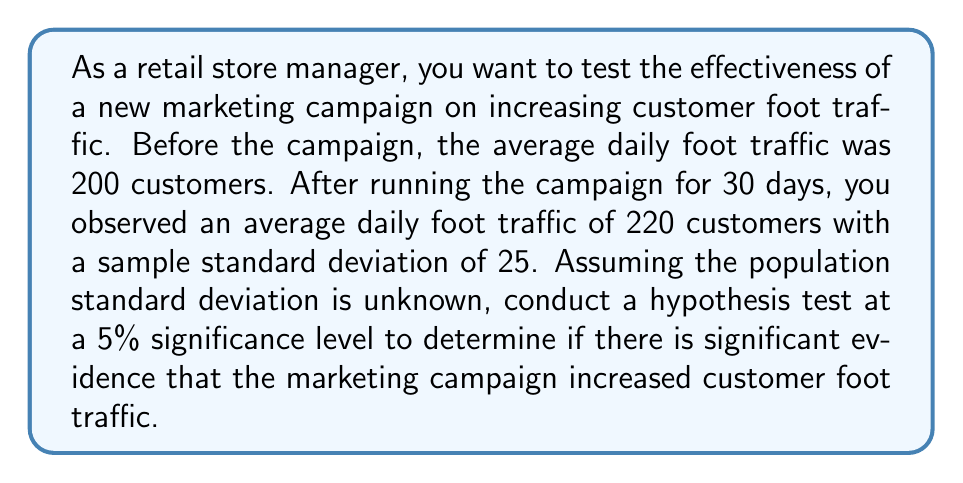Help me with this question. 1. Define the hypotheses:
   $H_0: \mu = 200$ (null hypothesis)
   $H_a: \mu > 200$ (alternative hypothesis)

2. Choose the significance level: $\alpha = 0.05$

3. Calculate the test statistic:
   $t = \frac{\bar{x} - \mu_0}{s/\sqrt{n}}$
   Where:
   $\bar{x} = 220$ (sample mean)
   $\mu_0 = 200$ (hypothesized population mean)
   $s = 25$ (sample standard deviation)
   $n = 30$ (sample size)

   $t = \frac{220 - 200}{25/\sqrt{30}} = \frac{20}{4.56} = 4.39$

4. Determine the critical value:
   Degrees of freedom: $df = n - 1 = 30 - 1 = 29$
   For a one-tailed test with $\alpha = 0.05$ and $df = 29$, the critical t-value is approximately 1.699.

5. Compare the test statistic to the critical value:
   $4.39 > 1.699$, so we reject the null hypothesis.

6. Calculate the p-value:
   Using a t-distribution table or calculator, we find that the p-value for $t = 4.39$ with $df = 29$ is approximately 0.0001, which is less than $\alpha = 0.05$.

7. Conclusion:
   Since the test statistic (4.39) is greater than the critical value (1.699) and the p-value (0.0001) is less than the significance level (0.05), we reject the null hypothesis. There is significant evidence to conclude that the marketing campaign increased customer foot traffic.
Answer: Reject $H_0$; significant evidence of increased foot traffic (t = 4.39, p < 0.05) 